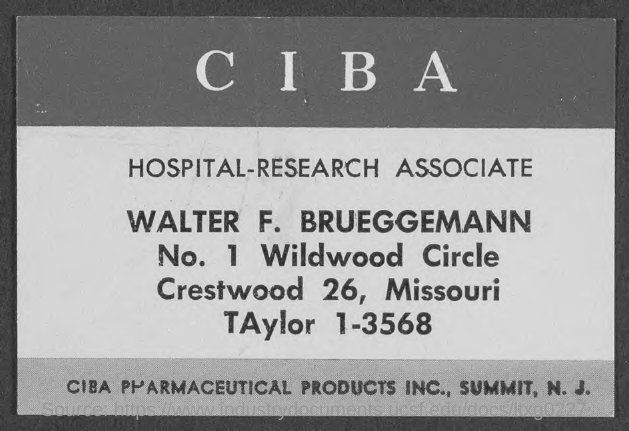Who is the Hospital- Research Associate given in the document?
Make the answer very short. Walter f. brueggemann. 